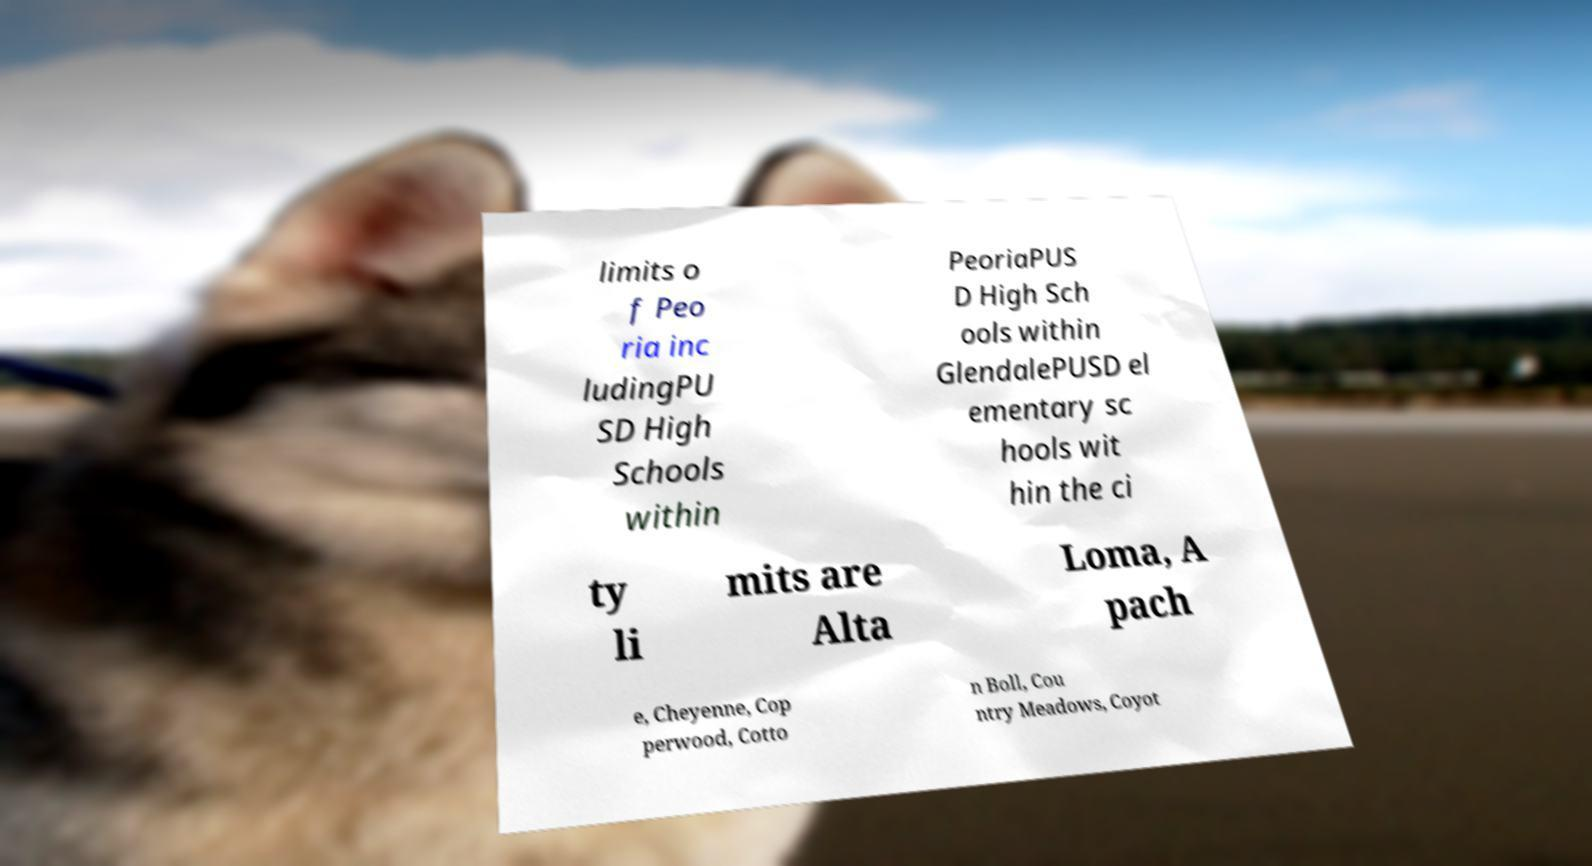Could you extract and type out the text from this image? limits o f Peo ria inc ludingPU SD High Schools within PeoriaPUS D High Sch ools within GlendalePUSD el ementary sc hools wit hin the ci ty li mits are Alta Loma, A pach e, Cheyenne, Cop perwood, Cotto n Boll, Cou ntry Meadows, Coyot 